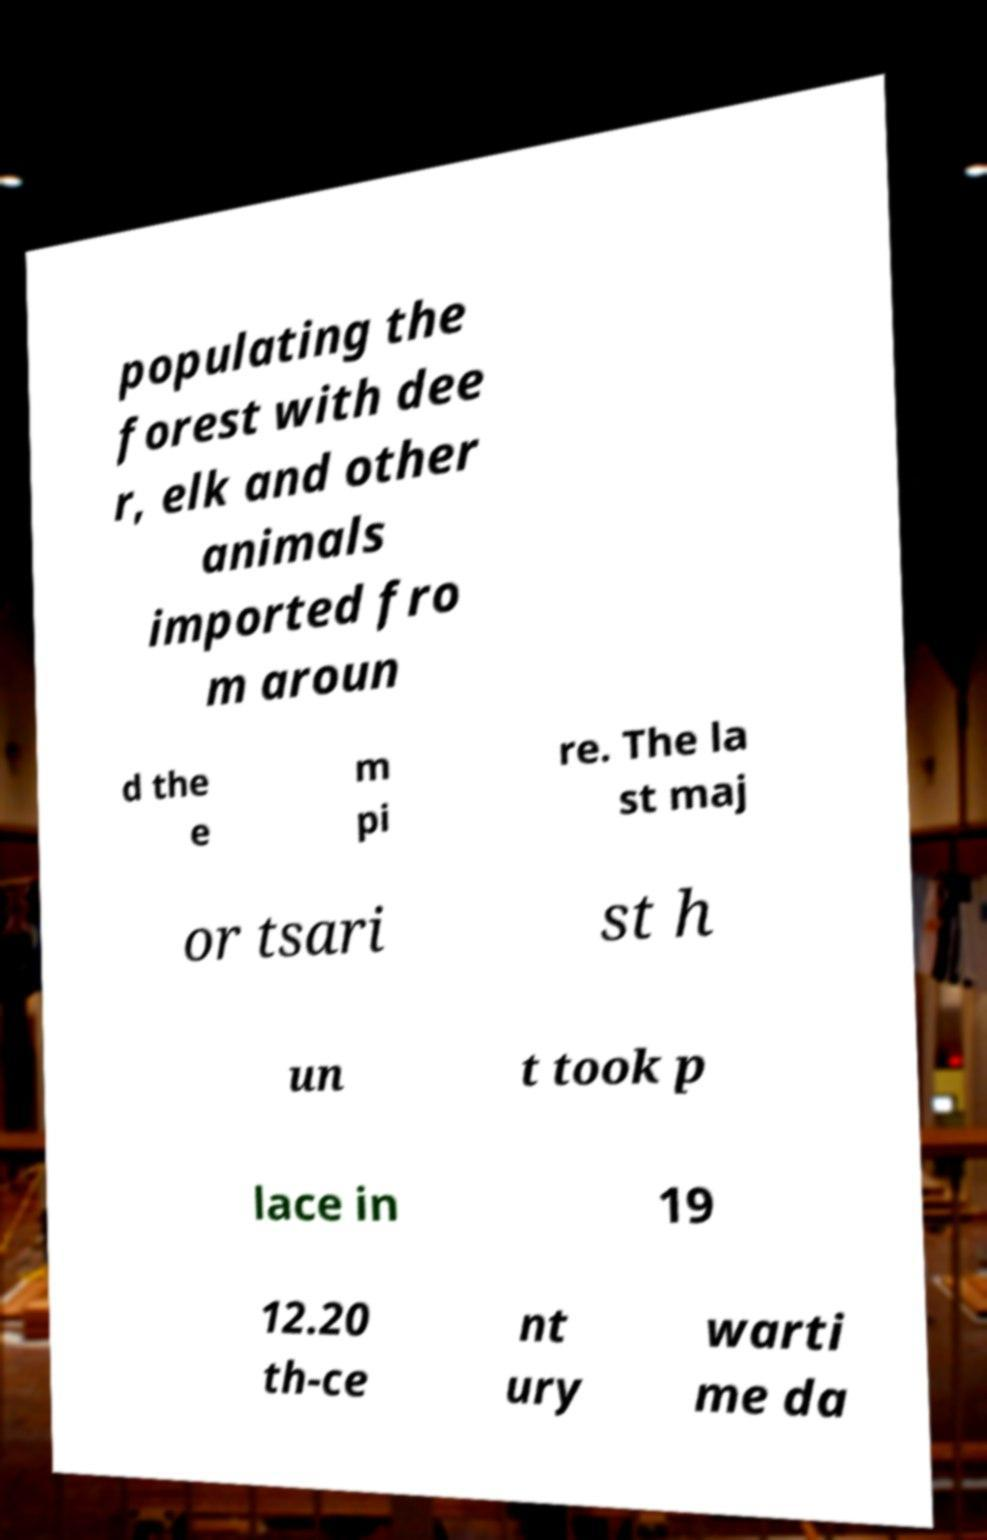I need the written content from this picture converted into text. Can you do that? populating the forest with dee r, elk and other animals imported fro m aroun d the e m pi re. The la st maj or tsari st h un t took p lace in 19 12.20 th-ce nt ury warti me da 